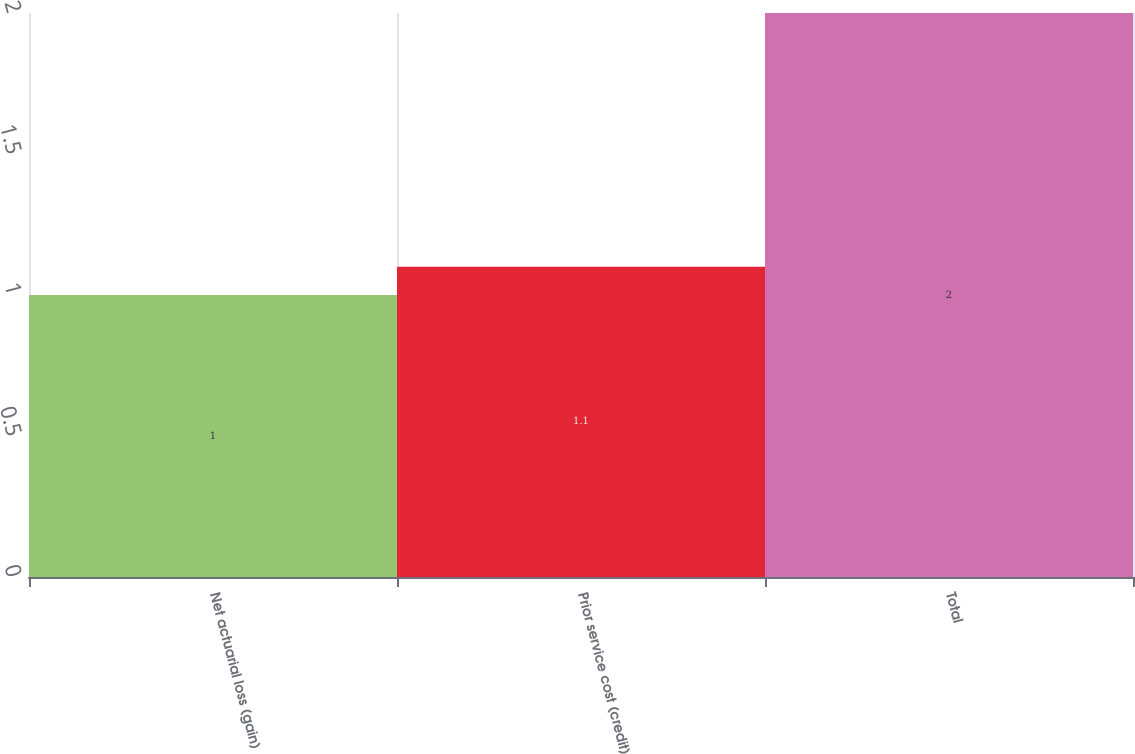Convert chart to OTSL. <chart><loc_0><loc_0><loc_500><loc_500><bar_chart><fcel>Net actuarial loss (gain)<fcel>Prior service cost (credit)<fcel>Total<nl><fcel>1<fcel>1.1<fcel>2<nl></chart> 